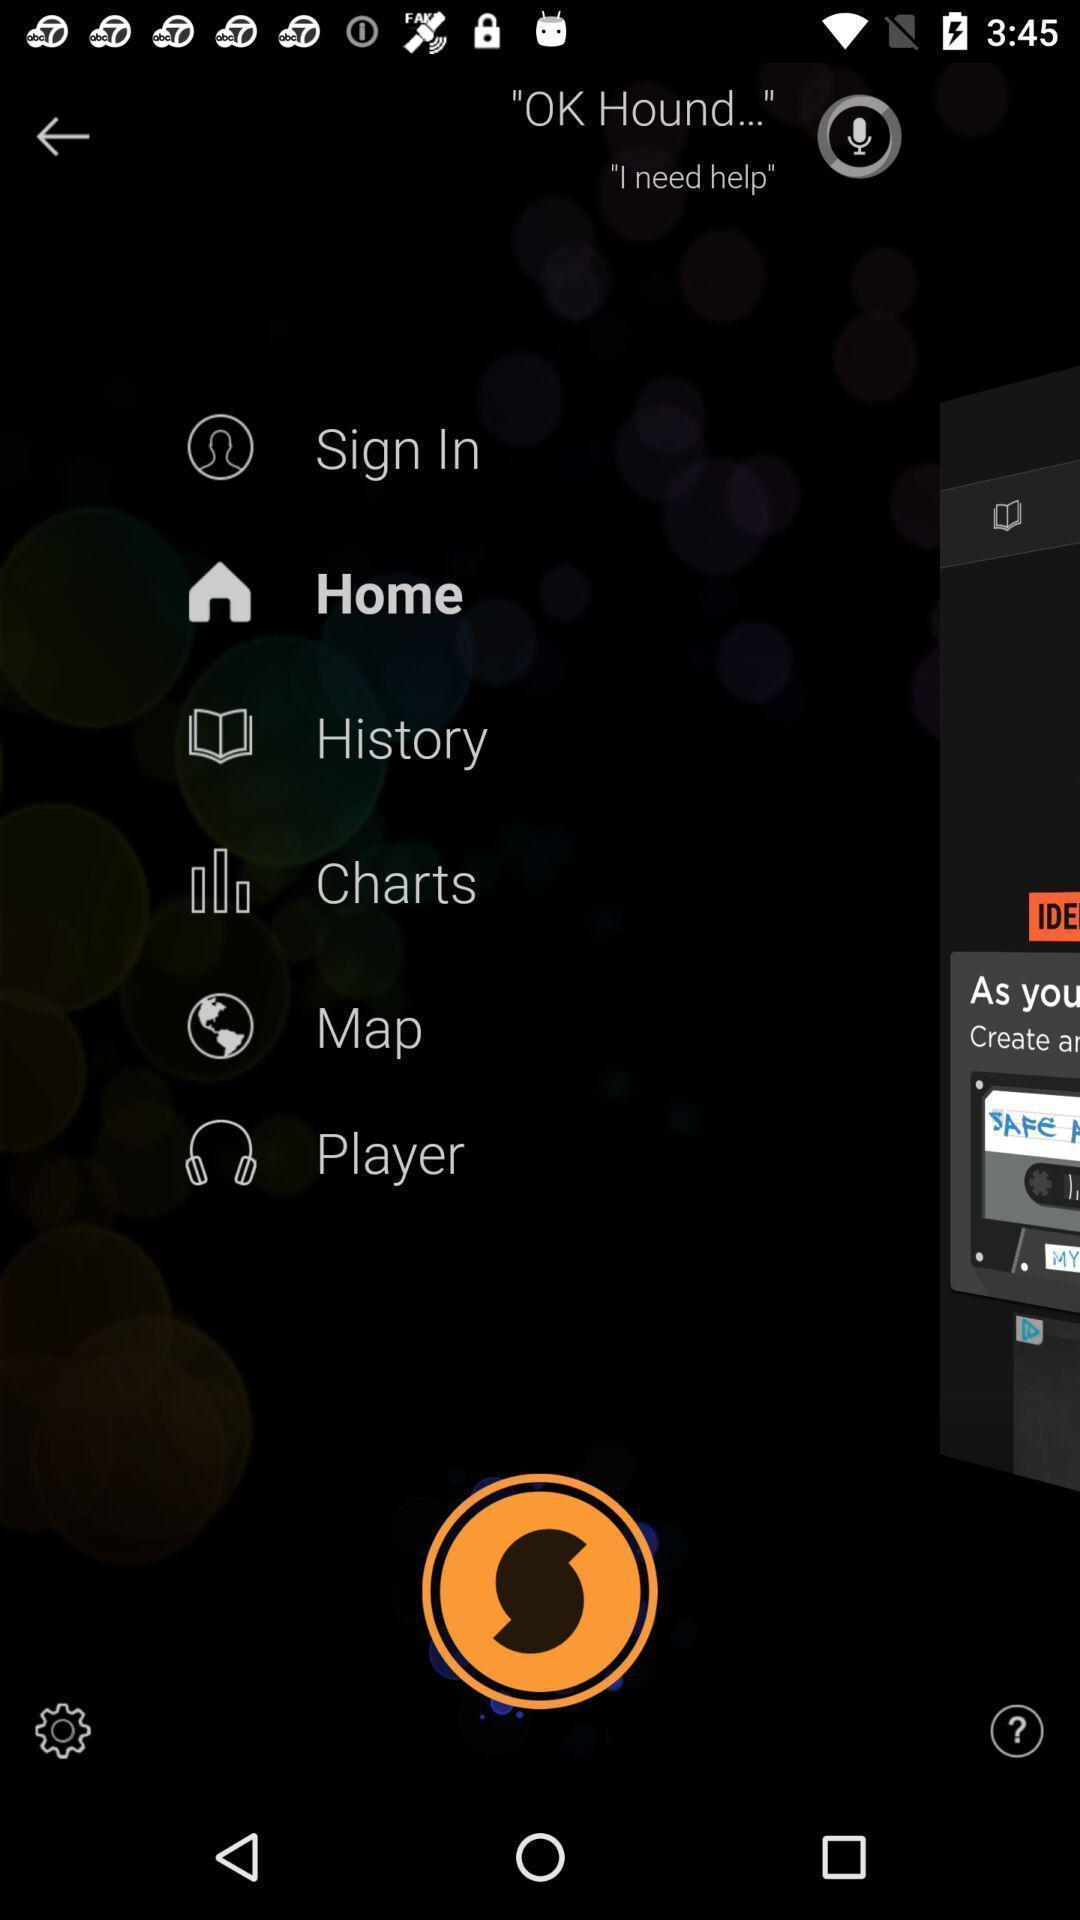Provide a textual representation of this image. List of options in the app. 